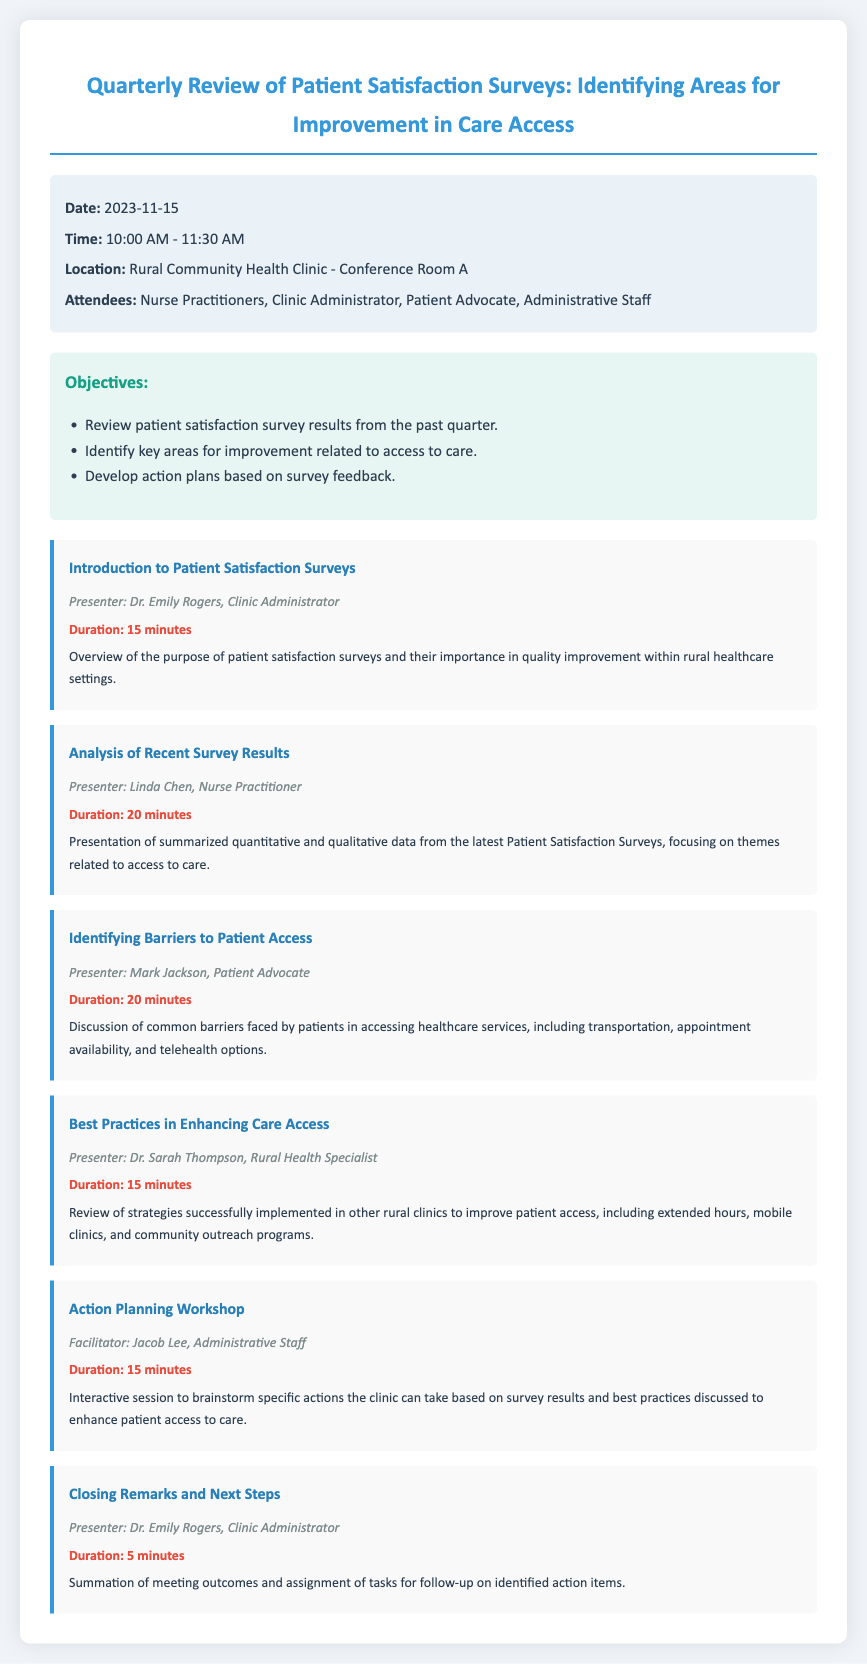What is the date of the meeting? The date of the meeting is specified in the information section of the document.
Answer: 2023-11-15 Who is the presenter for the introduction? The presenter is mentioned in the agenda section, particularly for the "Introduction to Patient Satisfaction Surveys."
Answer: Dr. Emily Rogers How long is the "Action Planning Workshop"? The duration is noted next to the agenda item for the "Action Planning Workshop."
Answer: 15 minutes What is one barrier to patient access discussed in the meeting? The barriers to patient access are outlined in the agenda item regarding barriers faced by patients.
Answer: Transportation What is one best practice for enhancing care access mentioned? The best practices are reviewed in the respective agenda item focusing on strategies implemented in other clinics.
Answer: Mobile clinics How many attendees are expected at the meeting? The document lists the types of attendees included in the meeting details.
Answer: Nurse Practitioners, Clinic Administrator, Patient Advocate, Administrative Staff What is the total duration of the meeting? The duration is calculated by summing up the time allocated for each agenda item.
Answer: 90 minutes What follows the "Closing Remarks and Next Steps" section? The agenda implies action items assigned after closing remarks.
Answer: Assignment of tasks for follow-up 